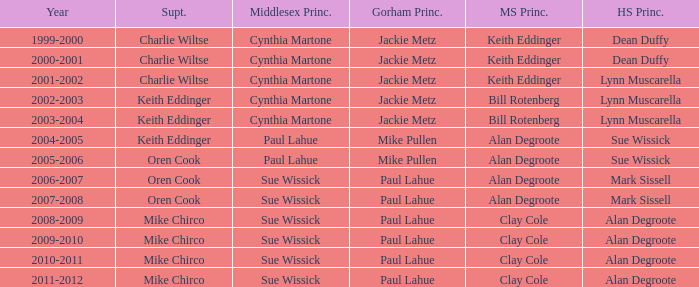Who was the gorham principal in 2010-2011? Paul Lahue. Could you parse the entire table as a dict? {'header': ['Year', 'Supt.', 'Middlesex Princ.', 'Gorham Princ.', 'MS Princ.', 'HS Princ.'], 'rows': [['1999-2000', 'Charlie Wiltse', 'Cynthia Martone', 'Jackie Metz', 'Keith Eddinger', 'Dean Duffy'], ['2000-2001', 'Charlie Wiltse', 'Cynthia Martone', 'Jackie Metz', 'Keith Eddinger', 'Dean Duffy'], ['2001-2002', 'Charlie Wiltse', 'Cynthia Martone', 'Jackie Metz', 'Keith Eddinger', 'Lynn Muscarella'], ['2002-2003', 'Keith Eddinger', 'Cynthia Martone', 'Jackie Metz', 'Bill Rotenberg', 'Lynn Muscarella'], ['2003-2004', 'Keith Eddinger', 'Cynthia Martone', 'Jackie Metz', 'Bill Rotenberg', 'Lynn Muscarella'], ['2004-2005', 'Keith Eddinger', 'Paul Lahue', 'Mike Pullen', 'Alan Degroote', 'Sue Wissick'], ['2005-2006', 'Oren Cook', 'Paul Lahue', 'Mike Pullen', 'Alan Degroote', 'Sue Wissick'], ['2006-2007', 'Oren Cook', 'Sue Wissick', 'Paul Lahue', 'Alan Degroote', 'Mark Sissell'], ['2007-2008', 'Oren Cook', 'Sue Wissick', 'Paul Lahue', 'Alan Degroote', 'Mark Sissell'], ['2008-2009', 'Mike Chirco', 'Sue Wissick', 'Paul Lahue', 'Clay Cole', 'Alan Degroote'], ['2009-2010', 'Mike Chirco', 'Sue Wissick', 'Paul Lahue', 'Clay Cole', 'Alan Degroote'], ['2010-2011', 'Mike Chirco', 'Sue Wissick', 'Paul Lahue', 'Clay Cole', 'Alan Degroote'], ['2011-2012', 'Mike Chirco', 'Sue Wissick', 'Paul Lahue', 'Clay Cole', 'Alan Degroote']]} 